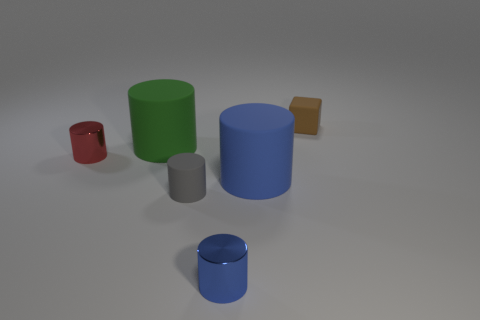Are there any green objects that are in front of the large rubber cylinder that is to the left of the small rubber thing that is to the left of the brown rubber thing?
Your answer should be very brief. No. The big thing that is behind the small cylinder to the left of the gray rubber object is made of what material?
Make the answer very short. Rubber. What is the thing that is both behind the red object and in front of the brown matte thing made of?
Offer a terse response. Rubber. Is there a small red metallic object that has the same shape as the brown matte thing?
Ensure brevity in your answer.  No. There is a big rubber cylinder that is behind the small red shiny thing; are there any tiny matte cylinders that are to the right of it?
Provide a succinct answer. Yes. What number of big green cylinders have the same material as the tiny gray thing?
Ensure brevity in your answer.  1. Are there any big yellow matte cubes?
Give a very brief answer. No. Are the gray cylinder and the thing that is left of the green matte object made of the same material?
Provide a succinct answer. No. Is the number of large green objects that are on the left side of the gray cylinder greater than the number of purple spheres?
Your response must be concise. Yes. Is the number of green matte objects that are to the left of the red cylinder the same as the number of red metallic cylinders right of the green thing?
Your answer should be very brief. Yes. 